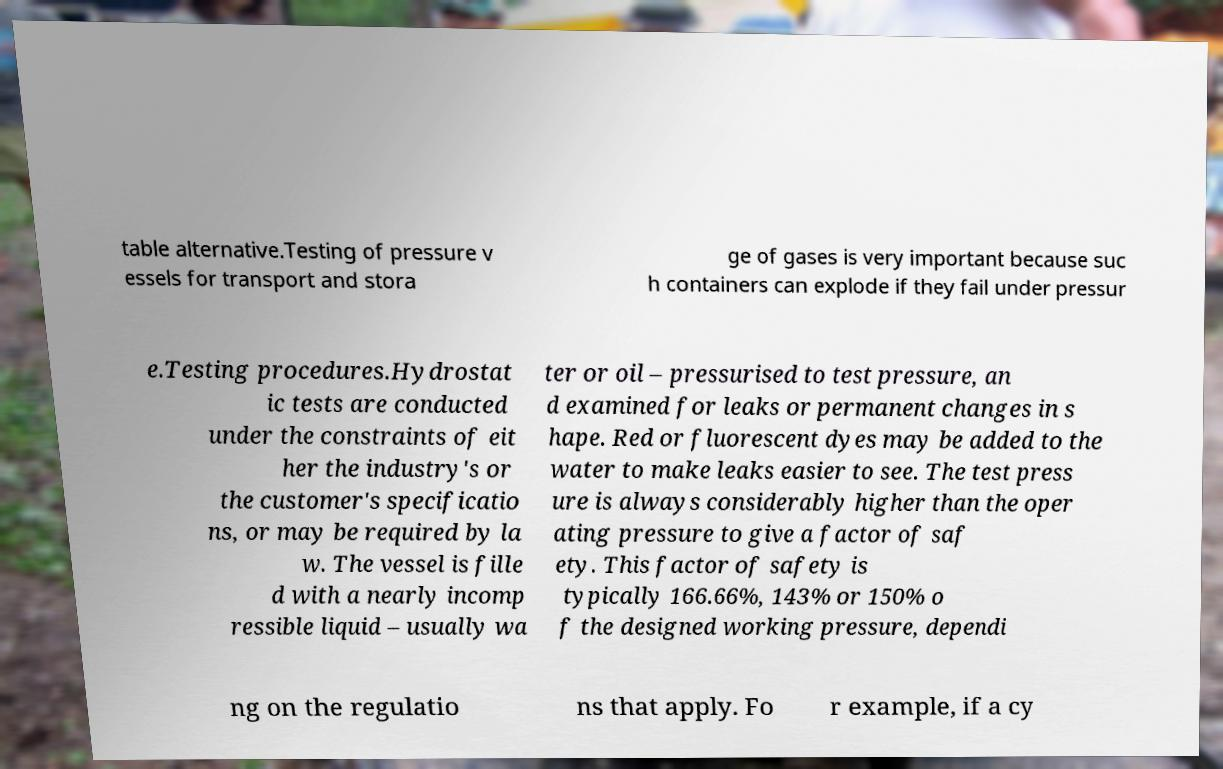Please identify and transcribe the text found in this image. table alternative.Testing of pressure v essels for transport and stora ge of gases is very important because suc h containers can explode if they fail under pressur e.Testing procedures.Hydrostat ic tests are conducted under the constraints of eit her the industry's or the customer's specificatio ns, or may be required by la w. The vessel is fille d with a nearly incomp ressible liquid – usually wa ter or oil – pressurised to test pressure, an d examined for leaks or permanent changes in s hape. Red or fluorescent dyes may be added to the water to make leaks easier to see. The test press ure is always considerably higher than the oper ating pressure to give a factor of saf ety. This factor of safety is typically 166.66%, 143% or 150% o f the designed working pressure, dependi ng on the regulatio ns that apply. Fo r example, if a cy 